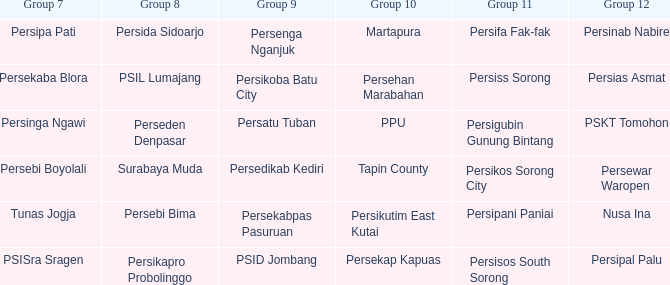Who played in group 8 when Persinab Nabire played in Group 12? Persida Sidoarjo. 